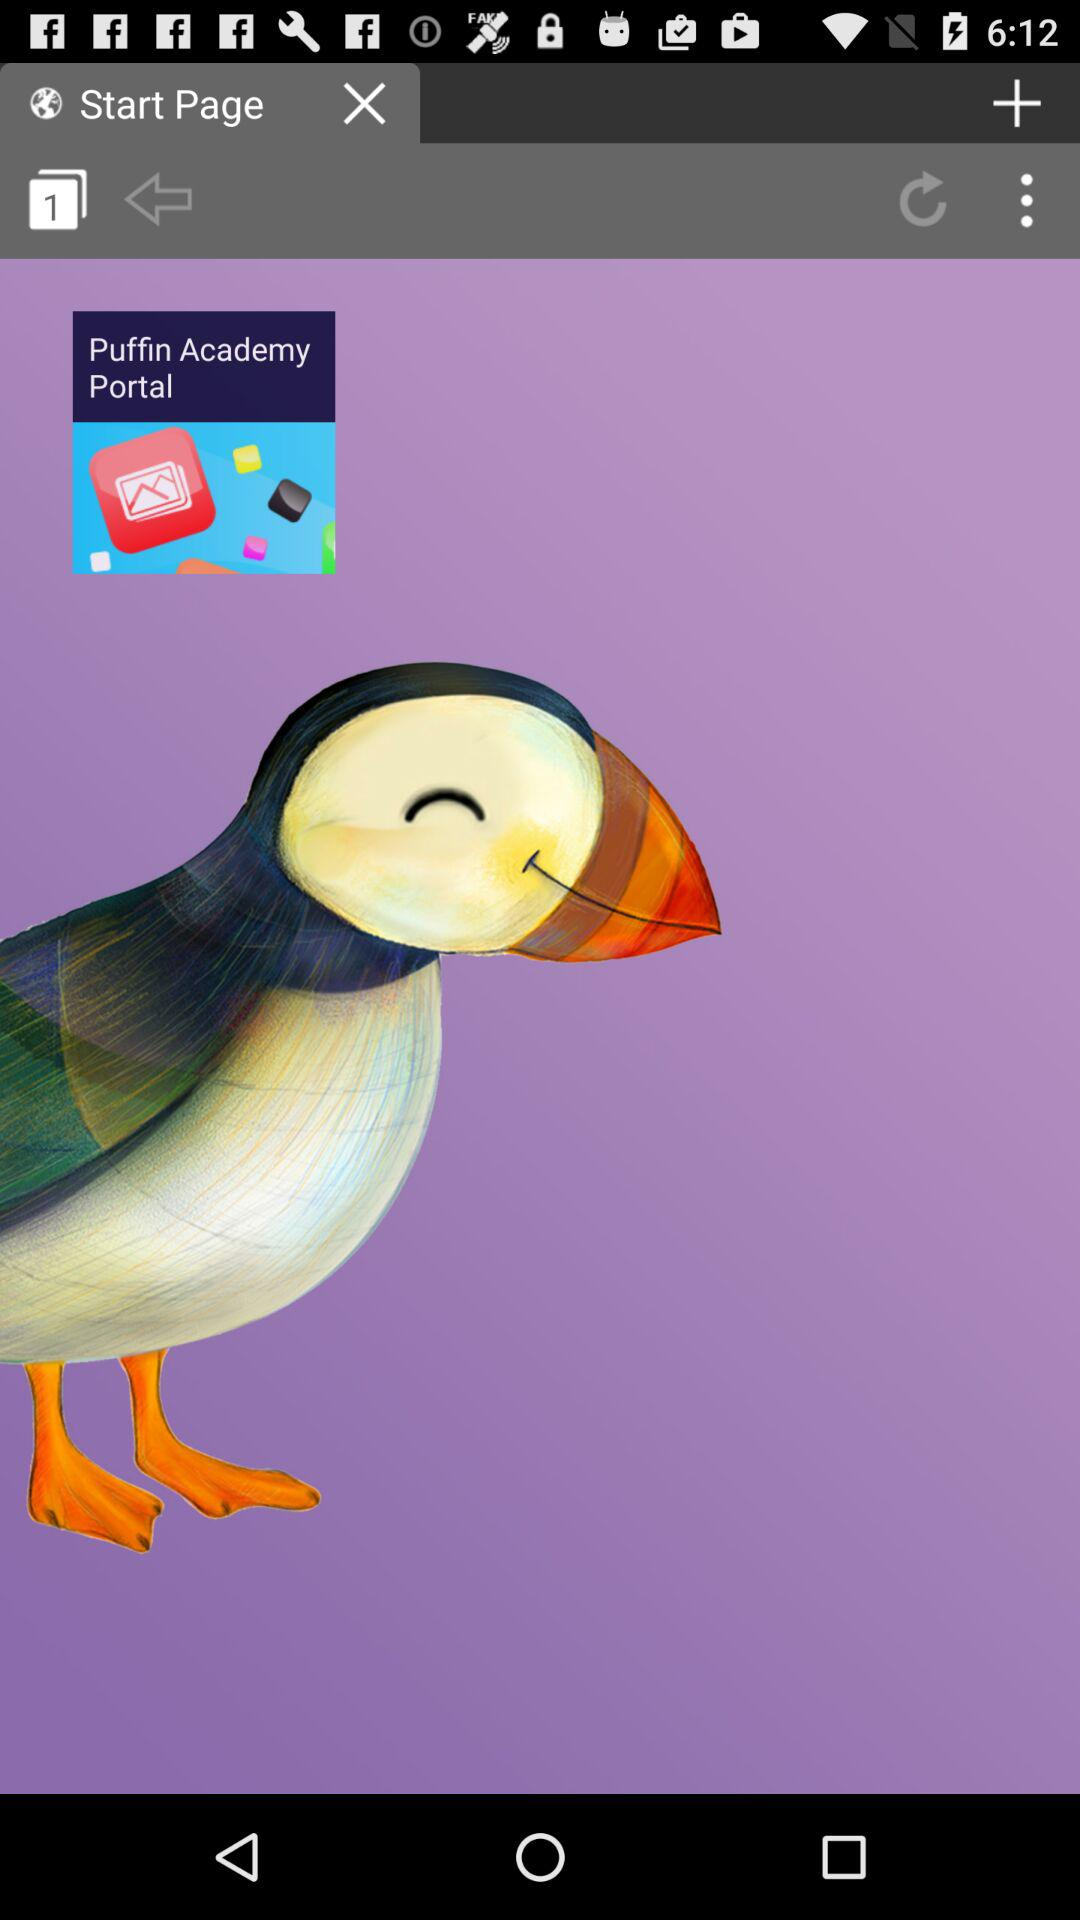Which user's account is connected to the browser?
When the provided information is insufficient, respond with <no answer>. <no answer> 